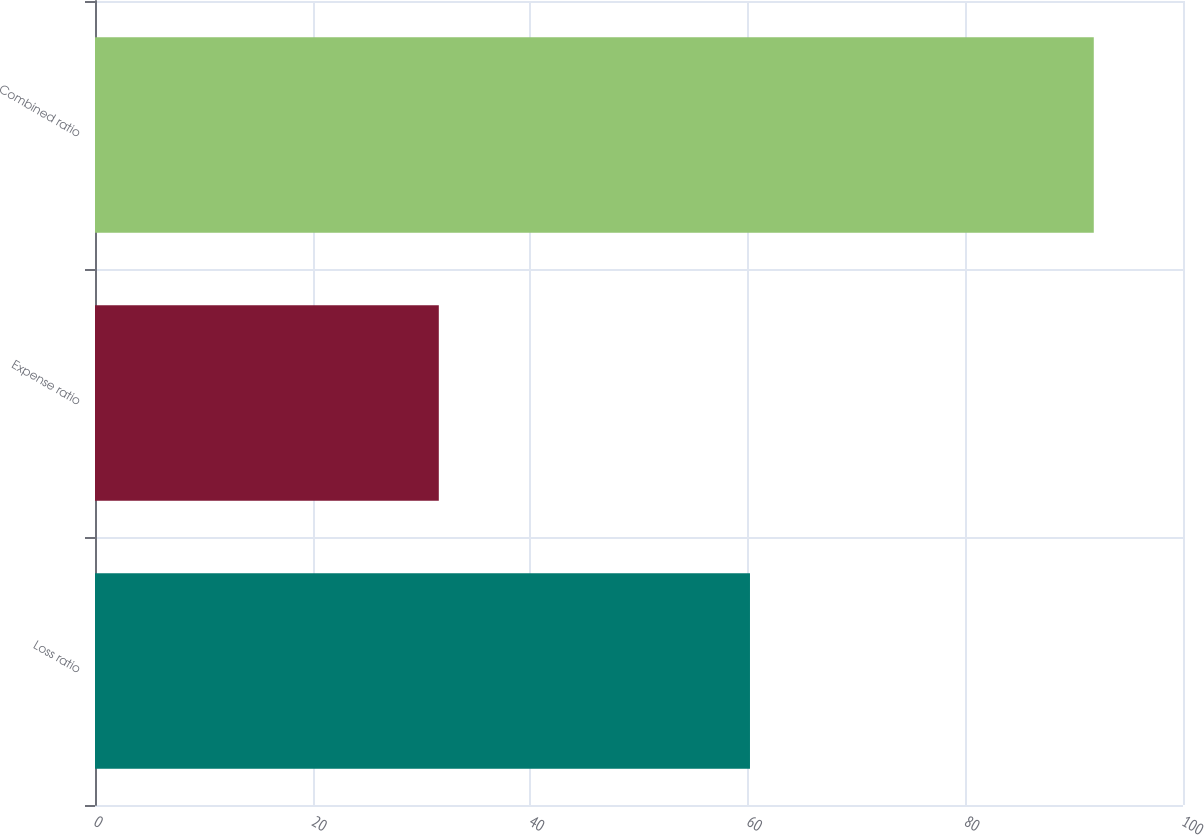<chart> <loc_0><loc_0><loc_500><loc_500><bar_chart><fcel>Loss ratio<fcel>Expense ratio<fcel>Combined ratio<nl><fcel>60.2<fcel>31.6<fcel>91.8<nl></chart> 